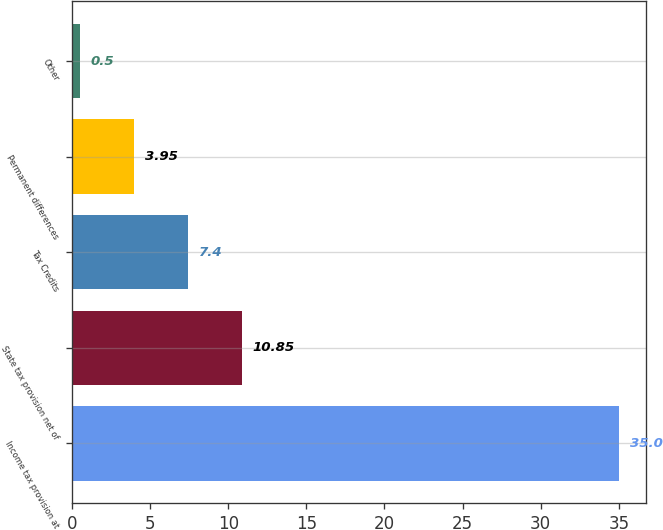Convert chart. <chart><loc_0><loc_0><loc_500><loc_500><bar_chart><fcel>Income tax provision at<fcel>State tax provision net of<fcel>Tax Credits<fcel>Permanent differences<fcel>Other<nl><fcel>35<fcel>10.85<fcel>7.4<fcel>3.95<fcel>0.5<nl></chart> 